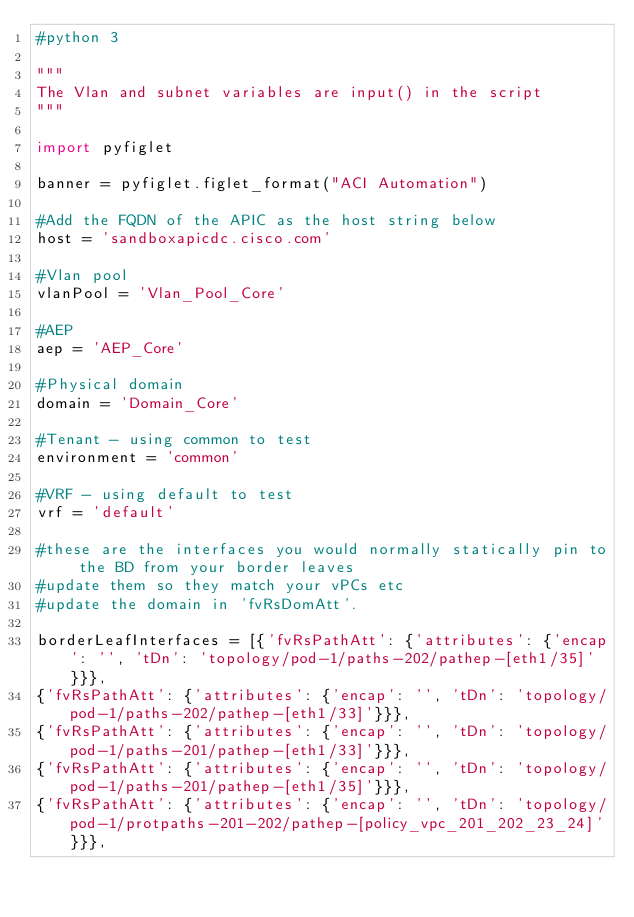Convert code to text. <code><loc_0><loc_0><loc_500><loc_500><_Python_>#python 3

"""
The Vlan and subnet variables are input() in the script
"""

import pyfiglet

banner = pyfiglet.figlet_format("ACI Automation")

#Add the FQDN of the APIC as the host string below
host = 'sandboxapicdc.cisco.com'

#Vlan pool
vlanPool = 'Vlan_Pool_Core'

#AEP
aep = 'AEP_Core'

#Physical domain
domain = 'Domain_Core'

#Tenant - using common to test
environment = 'common'

#VRF - using default to test
vrf = 'default'

#these are the interfaces you would normally statically pin to the BD from your border leaves
#update them so they match your vPCs etc
#update the domain in 'fvRsDomAtt'. 
  
borderLeafInterfaces = [{'fvRsPathAtt': {'attributes': {'encap': '', 'tDn': 'topology/pod-1/paths-202/pathep-[eth1/35]'}}},
{'fvRsPathAtt': {'attributes': {'encap': '', 'tDn': 'topology/pod-1/paths-202/pathep-[eth1/33]'}}},
{'fvRsPathAtt': {'attributes': {'encap': '', 'tDn': 'topology/pod-1/paths-201/pathep-[eth1/33]'}}},
{'fvRsPathAtt': {'attributes': {'encap': '', 'tDn': 'topology/pod-1/paths-201/pathep-[eth1/35]'}}},
{'fvRsPathAtt': {'attributes': {'encap': '', 'tDn': 'topology/pod-1/protpaths-201-202/pathep-[policy_vpc_201_202_23_24]'}}},</code> 